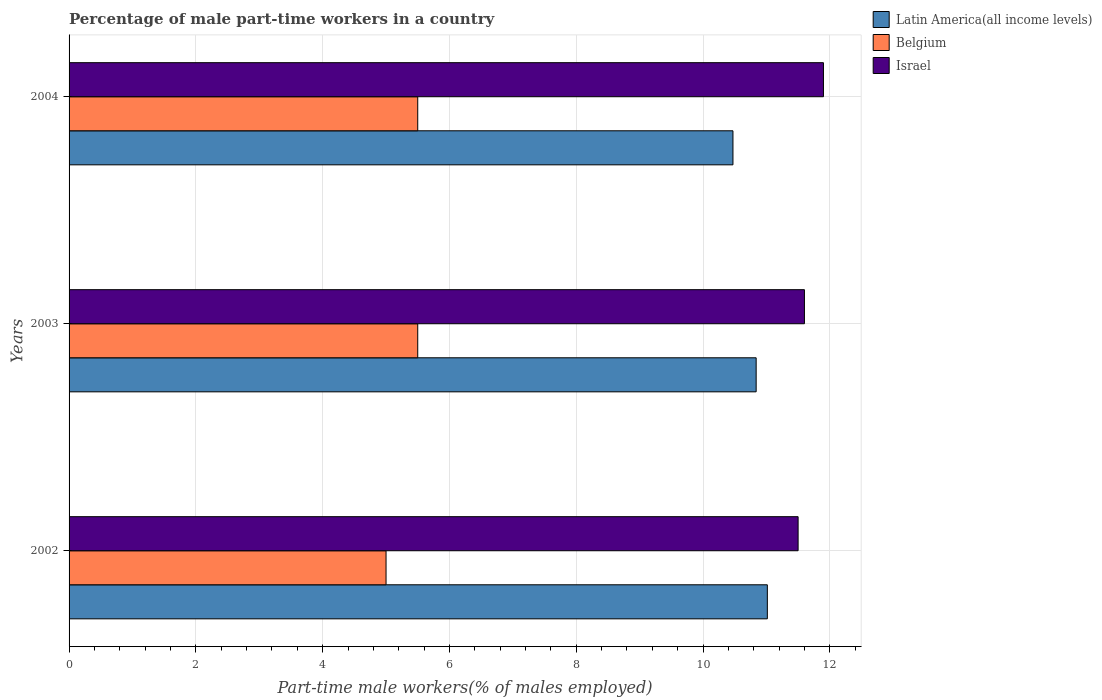How many groups of bars are there?
Make the answer very short. 3. Are the number of bars on each tick of the Y-axis equal?
Provide a succinct answer. Yes. How many bars are there on the 3rd tick from the top?
Ensure brevity in your answer.  3. Across all years, what is the maximum percentage of male part-time workers in Latin America(all income levels)?
Your answer should be very brief. 11.01. In which year was the percentage of male part-time workers in Belgium maximum?
Offer a very short reply. 2003. What is the total percentage of male part-time workers in Israel in the graph?
Provide a short and direct response. 35. What is the difference between the percentage of male part-time workers in Israel in 2004 and the percentage of male part-time workers in Belgium in 2002?
Offer a very short reply. 6.9. What is the average percentage of male part-time workers in Belgium per year?
Ensure brevity in your answer.  5.33. In the year 2003, what is the difference between the percentage of male part-time workers in Latin America(all income levels) and percentage of male part-time workers in Belgium?
Your answer should be compact. 5.34. In how many years, is the percentage of male part-time workers in Israel greater than 6 %?
Ensure brevity in your answer.  3. What is the ratio of the percentage of male part-time workers in Israel in 2002 to that in 2004?
Your response must be concise. 0.97. Is the percentage of male part-time workers in Latin America(all income levels) in 2003 less than that in 2004?
Keep it short and to the point. No. Is the difference between the percentage of male part-time workers in Latin America(all income levels) in 2002 and 2003 greater than the difference between the percentage of male part-time workers in Belgium in 2002 and 2003?
Keep it short and to the point. Yes. What is the difference between the highest and the second highest percentage of male part-time workers in Latin America(all income levels)?
Offer a terse response. 0.18. What is the difference between the highest and the lowest percentage of male part-time workers in Israel?
Your answer should be compact. 0.4. In how many years, is the percentage of male part-time workers in Latin America(all income levels) greater than the average percentage of male part-time workers in Latin America(all income levels) taken over all years?
Offer a terse response. 2. Is the sum of the percentage of male part-time workers in Latin America(all income levels) in 2002 and 2003 greater than the maximum percentage of male part-time workers in Belgium across all years?
Offer a terse response. Yes. What does the 3rd bar from the top in 2003 represents?
Give a very brief answer. Latin America(all income levels). What does the 1st bar from the bottom in 2003 represents?
Provide a short and direct response. Latin America(all income levels). Is it the case that in every year, the sum of the percentage of male part-time workers in Latin America(all income levels) and percentage of male part-time workers in Israel is greater than the percentage of male part-time workers in Belgium?
Offer a terse response. Yes. Are all the bars in the graph horizontal?
Offer a very short reply. Yes. How many years are there in the graph?
Give a very brief answer. 3. What is the difference between two consecutive major ticks on the X-axis?
Offer a terse response. 2. Are the values on the major ticks of X-axis written in scientific E-notation?
Keep it short and to the point. No. Does the graph contain any zero values?
Make the answer very short. No. What is the title of the graph?
Provide a short and direct response. Percentage of male part-time workers in a country. What is the label or title of the X-axis?
Provide a short and direct response. Part-time male workers(% of males employed). What is the Part-time male workers(% of males employed) of Latin America(all income levels) in 2002?
Offer a terse response. 11.01. What is the Part-time male workers(% of males employed) in Israel in 2002?
Provide a short and direct response. 11.5. What is the Part-time male workers(% of males employed) of Latin America(all income levels) in 2003?
Offer a terse response. 10.84. What is the Part-time male workers(% of males employed) of Israel in 2003?
Ensure brevity in your answer.  11.6. What is the Part-time male workers(% of males employed) in Latin America(all income levels) in 2004?
Your answer should be compact. 10.47. What is the Part-time male workers(% of males employed) of Belgium in 2004?
Your answer should be compact. 5.5. What is the Part-time male workers(% of males employed) of Israel in 2004?
Provide a short and direct response. 11.9. Across all years, what is the maximum Part-time male workers(% of males employed) of Latin America(all income levels)?
Offer a very short reply. 11.01. Across all years, what is the maximum Part-time male workers(% of males employed) in Israel?
Provide a succinct answer. 11.9. Across all years, what is the minimum Part-time male workers(% of males employed) in Latin America(all income levels)?
Offer a very short reply. 10.47. Across all years, what is the minimum Part-time male workers(% of males employed) of Belgium?
Your answer should be very brief. 5. What is the total Part-time male workers(% of males employed) of Latin America(all income levels) in the graph?
Provide a succinct answer. 32.33. What is the total Part-time male workers(% of males employed) of Belgium in the graph?
Give a very brief answer. 16. What is the total Part-time male workers(% of males employed) of Israel in the graph?
Offer a terse response. 35. What is the difference between the Part-time male workers(% of males employed) in Latin America(all income levels) in 2002 and that in 2003?
Your answer should be compact. 0.18. What is the difference between the Part-time male workers(% of males employed) of Belgium in 2002 and that in 2003?
Give a very brief answer. -0.5. What is the difference between the Part-time male workers(% of males employed) in Israel in 2002 and that in 2003?
Provide a succinct answer. -0.1. What is the difference between the Part-time male workers(% of males employed) of Latin America(all income levels) in 2002 and that in 2004?
Your answer should be very brief. 0.54. What is the difference between the Part-time male workers(% of males employed) of Belgium in 2002 and that in 2004?
Your response must be concise. -0.5. What is the difference between the Part-time male workers(% of males employed) in Israel in 2002 and that in 2004?
Ensure brevity in your answer.  -0.4. What is the difference between the Part-time male workers(% of males employed) in Latin America(all income levels) in 2003 and that in 2004?
Keep it short and to the point. 0.37. What is the difference between the Part-time male workers(% of males employed) of Latin America(all income levels) in 2002 and the Part-time male workers(% of males employed) of Belgium in 2003?
Provide a succinct answer. 5.51. What is the difference between the Part-time male workers(% of males employed) of Latin America(all income levels) in 2002 and the Part-time male workers(% of males employed) of Israel in 2003?
Your answer should be very brief. -0.59. What is the difference between the Part-time male workers(% of males employed) in Belgium in 2002 and the Part-time male workers(% of males employed) in Israel in 2003?
Give a very brief answer. -6.6. What is the difference between the Part-time male workers(% of males employed) of Latin America(all income levels) in 2002 and the Part-time male workers(% of males employed) of Belgium in 2004?
Ensure brevity in your answer.  5.51. What is the difference between the Part-time male workers(% of males employed) in Latin America(all income levels) in 2002 and the Part-time male workers(% of males employed) in Israel in 2004?
Your answer should be very brief. -0.89. What is the difference between the Part-time male workers(% of males employed) in Belgium in 2002 and the Part-time male workers(% of males employed) in Israel in 2004?
Your response must be concise. -6.9. What is the difference between the Part-time male workers(% of males employed) in Latin America(all income levels) in 2003 and the Part-time male workers(% of males employed) in Belgium in 2004?
Ensure brevity in your answer.  5.34. What is the difference between the Part-time male workers(% of males employed) in Latin America(all income levels) in 2003 and the Part-time male workers(% of males employed) in Israel in 2004?
Give a very brief answer. -1.06. What is the difference between the Part-time male workers(% of males employed) in Belgium in 2003 and the Part-time male workers(% of males employed) in Israel in 2004?
Give a very brief answer. -6.4. What is the average Part-time male workers(% of males employed) in Latin America(all income levels) per year?
Provide a short and direct response. 10.78. What is the average Part-time male workers(% of males employed) in Belgium per year?
Provide a succinct answer. 5.33. What is the average Part-time male workers(% of males employed) in Israel per year?
Give a very brief answer. 11.67. In the year 2002, what is the difference between the Part-time male workers(% of males employed) in Latin America(all income levels) and Part-time male workers(% of males employed) in Belgium?
Ensure brevity in your answer.  6.01. In the year 2002, what is the difference between the Part-time male workers(% of males employed) in Latin America(all income levels) and Part-time male workers(% of males employed) in Israel?
Give a very brief answer. -0.49. In the year 2002, what is the difference between the Part-time male workers(% of males employed) of Belgium and Part-time male workers(% of males employed) of Israel?
Your response must be concise. -6.5. In the year 2003, what is the difference between the Part-time male workers(% of males employed) in Latin America(all income levels) and Part-time male workers(% of males employed) in Belgium?
Ensure brevity in your answer.  5.34. In the year 2003, what is the difference between the Part-time male workers(% of males employed) in Latin America(all income levels) and Part-time male workers(% of males employed) in Israel?
Give a very brief answer. -0.76. In the year 2004, what is the difference between the Part-time male workers(% of males employed) of Latin America(all income levels) and Part-time male workers(% of males employed) of Belgium?
Your answer should be very brief. 4.97. In the year 2004, what is the difference between the Part-time male workers(% of males employed) in Latin America(all income levels) and Part-time male workers(% of males employed) in Israel?
Your answer should be compact. -1.43. What is the ratio of the Part-time male workers(% of males employed) in Latin America(all income levels) in 2002 to that in 2003?
Make the answer very short. 1.02. What is the ratio of the Part-time male workers(% of males employed) of Belgium in 2002 to that in 2003?
Ensure brevity in your answer.  0.91. What is the ratio of the Part-time male workers(% of males employed) in Israel in 2002 to that in 2003?
Offer a terse response. 0.99. What is the ratio of the Part-time male workers(% of males employed) of Latin America(all income levels) in 2002 to that in 2004?
Give a very brief answer. 1.05. What is the ratio of the Part-time male workers(% of males employed) in Belgium in 2002 to that in 2004?
Your answer should be compact. 0.91. What is the ratio of the Part-time male workers(% of males employed) in Israel in 2002 to that in 2004?
Make the answer very short. 0.97. What is the ratio of the Part-time male workers(% of males employed) in Latin America(all income levels) in 2003 to that in 2004?
Provide a short and direct response. 1.03. What is the ratio of the Part-time male workers(% of males employed) in Israel in 2003 to that in 2004?
Your answer should be very brief. 0.97. What is the difference between the highest and the second highest Part-time male workers(% of males employed) in Latin America(all income levels)?
Your answer should be compact. 0.18. What is the difference between the highest and the lowest Part-time male workers(% of males employed) of Latin America(all income levels)?
Offer a terse response. 0.54. What is the difference between the highest and the lowest Part-time male workers(% of males employed) in Israel?
Offer a very short reply. 0.4. 